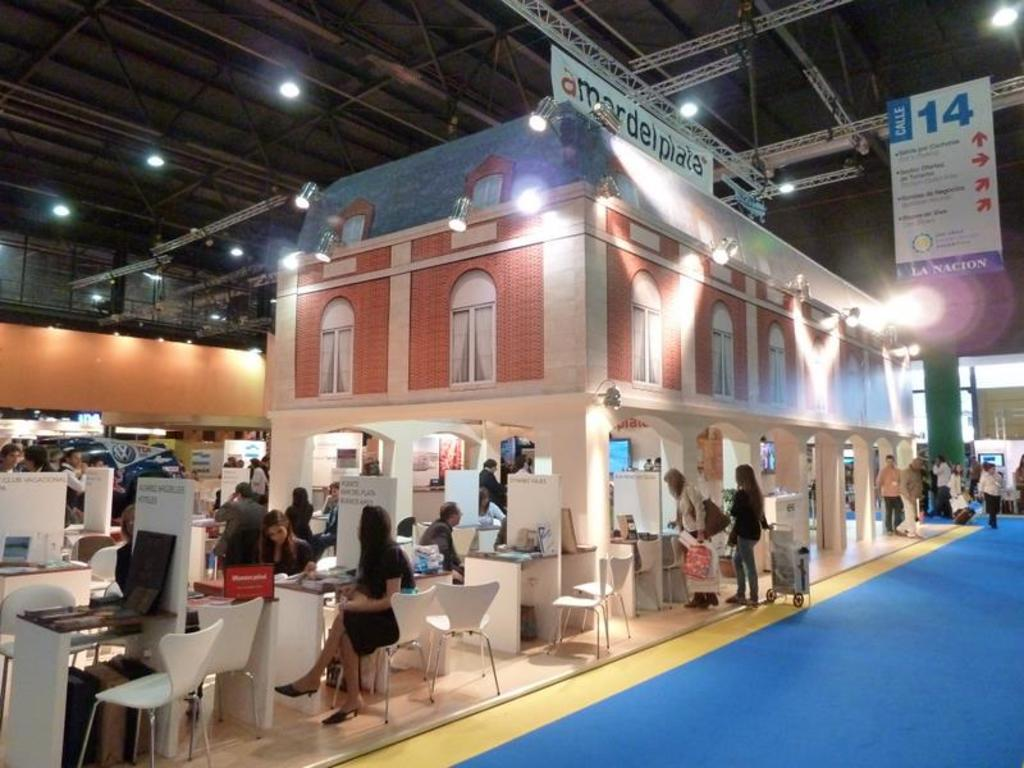What type of furniture is present in the image? There are tables and desks in the image. Are there any people in the image? Yes, there are people in the image. What kind of structure is visible in the image? There is a building in the image. What can be seen near the ceiling in the image? The lights and banners are near the ceiling. What items are being carried by the people in the image? There are bags in the image. What type of digestion is taking place in the image? There is no indication of digestion occurring in the image. Who is the owner of the building in the image? The image does not provide information about the owner of the building. 